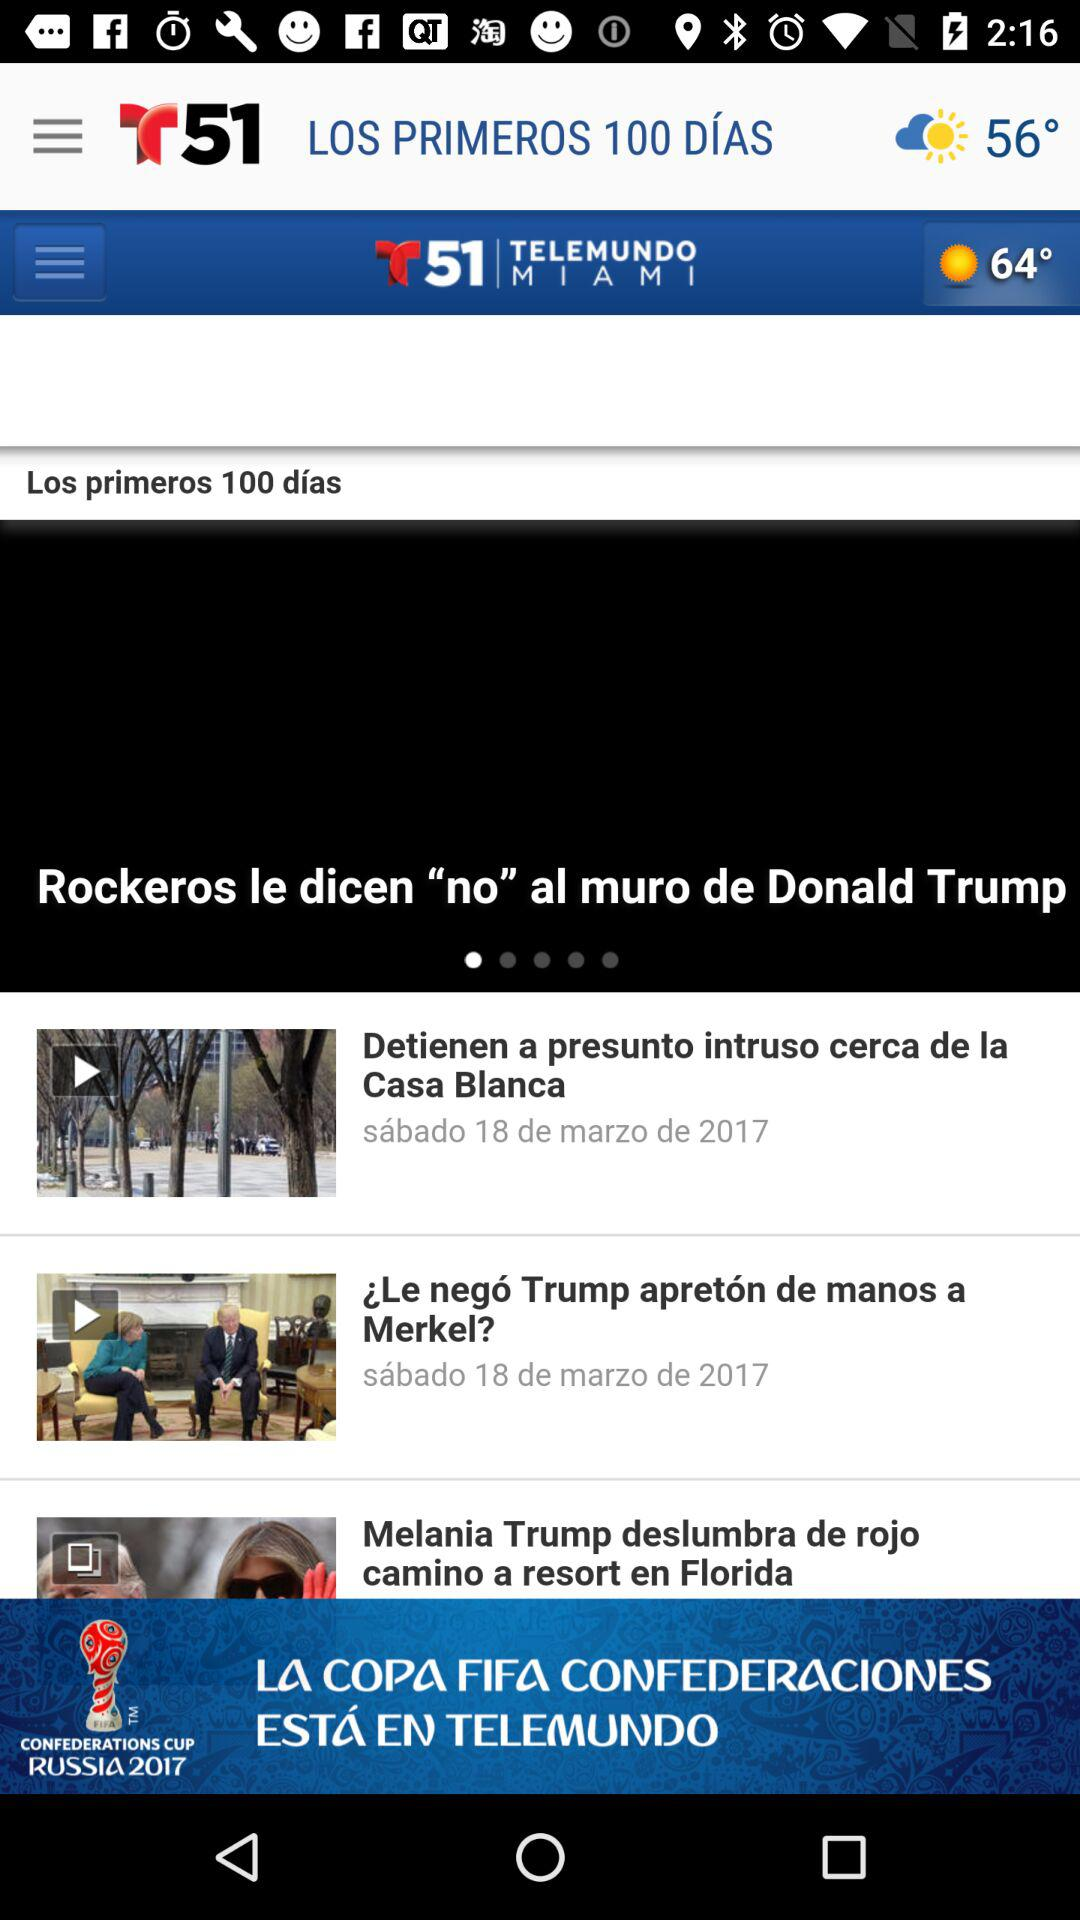How many more stories are there than news items?
Answer the question using a single word or phrase. 2 